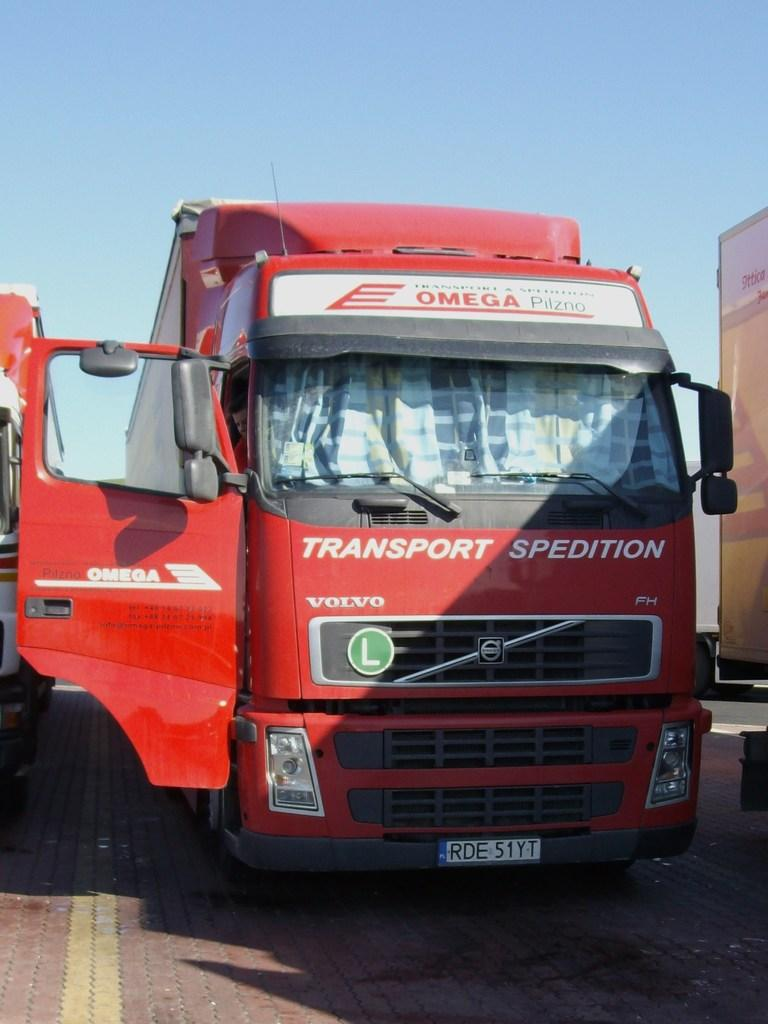What color is the vehicle in the image? There is a red vehicle in the image. Is there any text or writing on the red vehicle? Yes, there is writing on the red vehicle. Can you describe the other vehicle in the image? There is another vehicle beside the red vehicle. What suggestion does the red vehicle make to the other vehicle in the image? The red vehicle does not make any suggestions to the other vehicle in the image, as vehicles do not have the ability to communicate in this manner. 